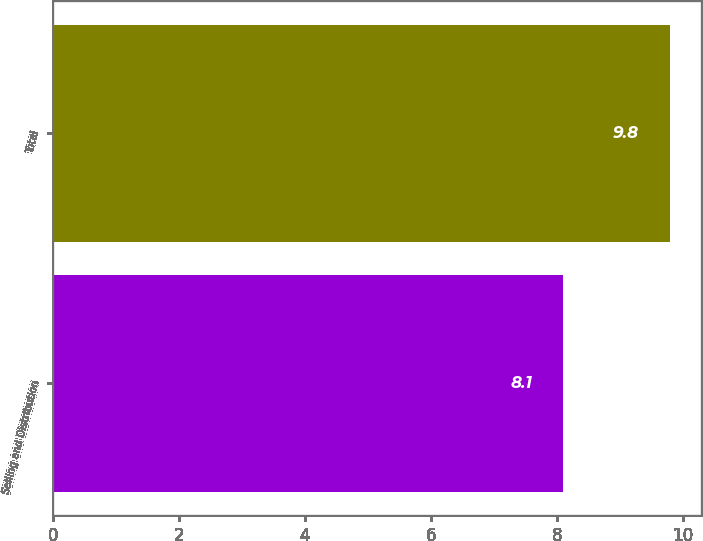Convert chart. <chart><loc_0><loc_0><loc_500><loc_500><bar_chart><fcel>Selling and Distribution<fcel>Total<nl><fcel>8.1<fcel>9.8<nl></chart> 